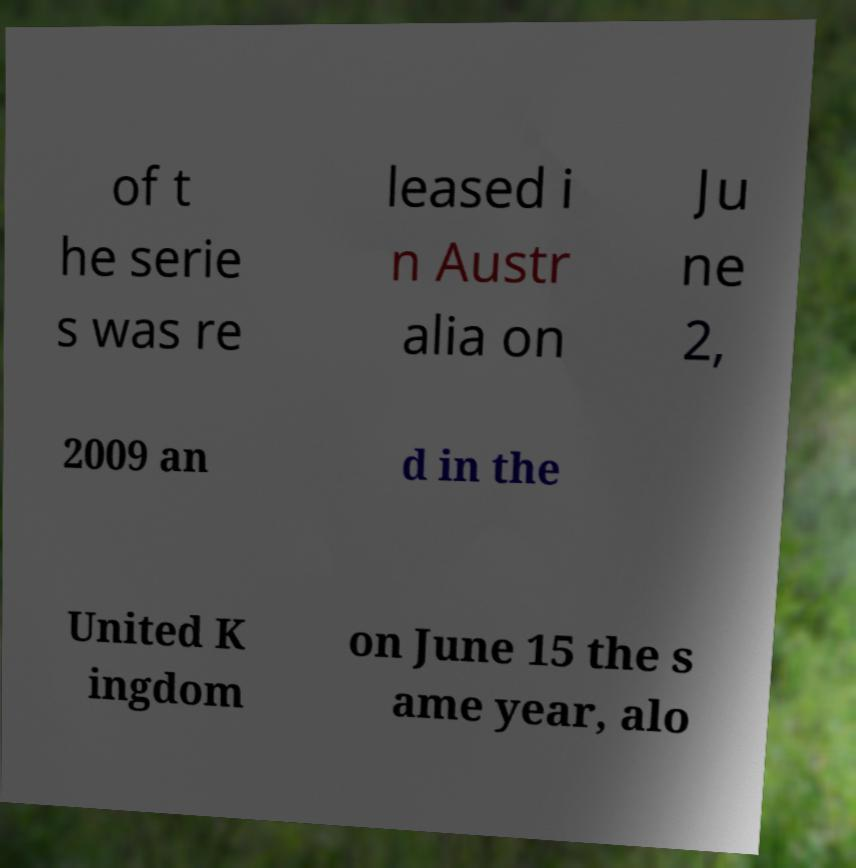Can you read and provide the text displayed in the image?This photo seems to have some interesting text. Can you extract and type it out for me? of t he serie s was re leased i n Austr alia on Ju ne 2, 2009 an d in the United K ingdom on June 15 the s ame year, alo 